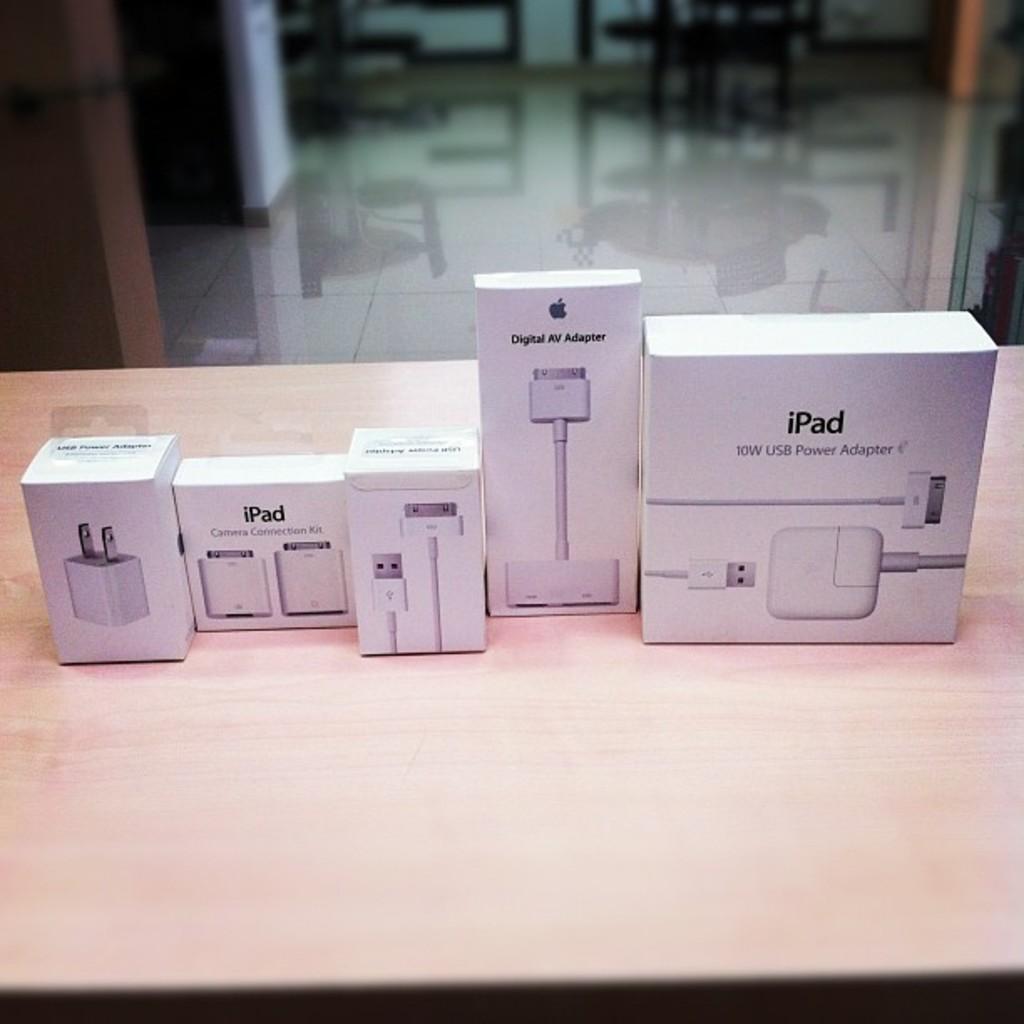What does this charger go to?
Ensure brevity in your answer.  Ipad. What does it say on the box that is second from the right?
Make the answer very short. Digital av adapter. 